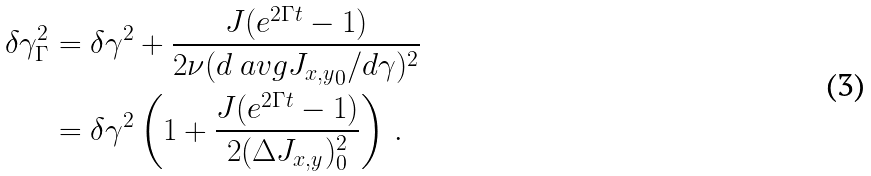Convert formula to latex. <formula><loc_0><loc_0><loc_500><loc_500>\delta \gamma _ { \Gamma } ^ { 2 } & = \delta \gamma ^ { 2 } + \frac { J ( e ^ { 2 \Gamma t } - 1 ) } { 2 \nu ( d \ a v g { J _ { x , y } } _ { 0 } / d \gamma ) ^ { 2 } } \\ & = \delta \gamma ^ { 2 } \left ( 1 + \frac { J ( e ^ { 2 \Gamma t } - 1 ) } { 2 ( \Delta J _ { x , y } ) ^ { 2 } _ { 0 } } \right ) \, .</formula> 